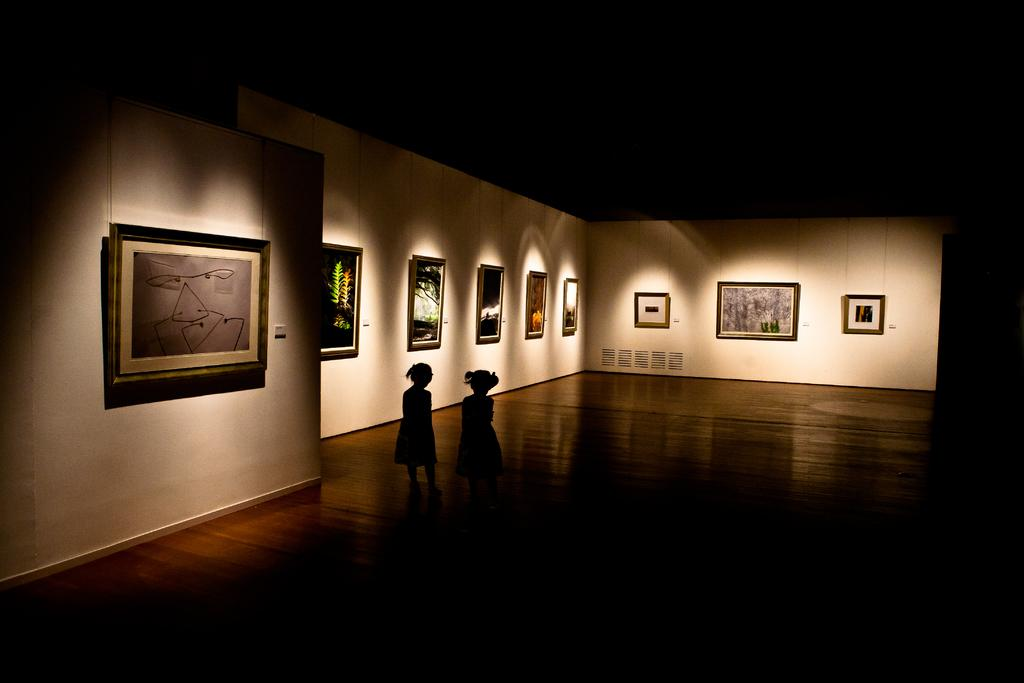How many people are present in the image? There are two people standing in the image. What can be seen in the background of the image? There are lights visible in the background, and frames are attached to the wall. What is the color of the background in the image? The background color is black. Is there any blood visible on the people in the image? No, there is no blood visible on the people in the image. What type of dinner is being served in the image? There is no dinner present in the image. 